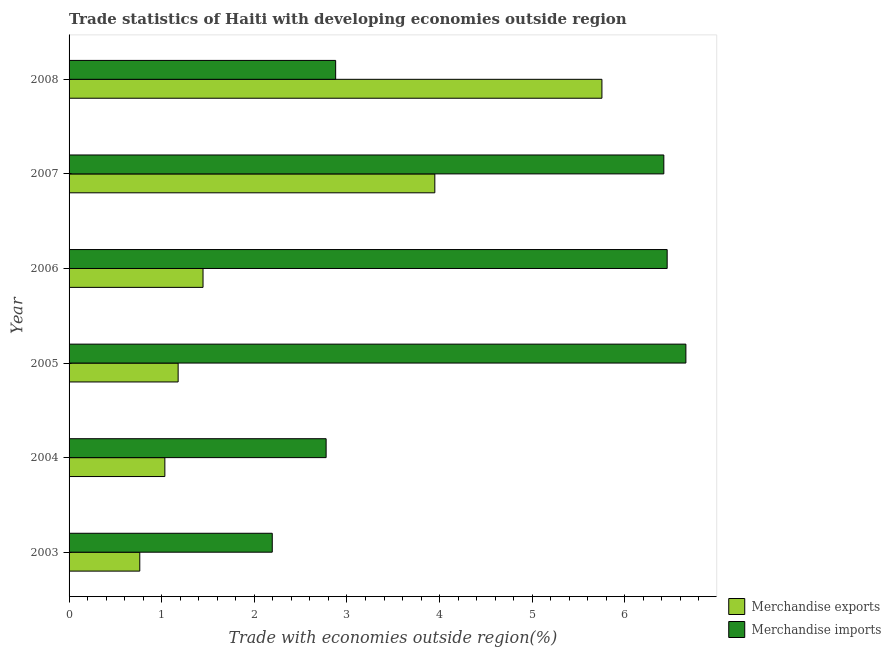How many groups of bars are there?
Ensure brevity in your answer.  6. Are the number of bars per tick equal to the number of legend labels?
Provide a succinct answer. Yes. How many bars are there on the 5th tick from the top?
Ensure brevity in your answer.  2. What is the label of the 5th group of bars from the top?
Offer a terse response. 2004. In how many cases, is the number of bars for a given year not equal to the number of legend labels?
Offer a very short reply. 0. What is the merchandise imports in 2004?
Offer a very short reply. 2.78. Across all years, what is the maximum merchandise imports?
Keep it short and to the point. 6.66. Across all years, what is the minimum merchandise exports?
Keep it short and to the point. 0.76. In which year was the merchandise exports minimum?
Offer a very short reply. 2003. What is the total merchandise exports in the graph?
Provide a short and direct response. 14.12. What is the difference between the merchandise exports in 2005 and that in 2007?
Provide a succinct answer. -2.77. What is the difference between the merchandise exports in 2004 and the merchandise imports in 2005?
Keep it short and to the point. -5.62. What is the average merchandise imports per year?
Your answer should be compact. 4.56. In the year 2005, what is the difference between the merchandise imports and merchandise exports?
Provide a succinct answer. 5.48. In how many years, is the merchandise exports greater than 6.6 %?
Make the answer very short. 0. Is the merchandise exports in 2006 less than that in 2008?
Make the answer very short. Yes. Is the difference between the merchandise exports in 2004 and 2007 greater than the difference between the merchandise imports in 2004 and 2007?
Your response must be concise. Yes. What is the difference between the highest and the second highest merchandise imports?
Provide a short and direct response. 0.2. What is the difference between the highest and the lowest merchandise exports?
Offer a terse response. 4.99. In how many years, is the merchandise imports greater than the average merchandise imports taken over all years?
Offer a very short reply. 3. Is the sum of the merchandise exports in 2003 and 2008 greater than the maximum merchandise imports across all years?
Provide a short and direct response. No. What does the 1st bar from the top in 2008 represents?
Give a very brief answer. Merchandise imports. What does the 2nd bar from the bottom in 2004 represents?
Give a very brief answer. Merchandise imports. Are all the bars in the graph horizontal?
Make the answer very short. Yes. Does the graph contain any zero values?
Provide a short and direct response. No. Does the graph contain grids?
Offer a terse response. No. Where does the legend appear in the graph?
Ensure brevity in your answer.  Bottom right. How many legend labels are there?
Ensure brevity in your answer.  2. How are the legend labels stacked?
Offer a very short reply. Vertical. What is the title of the graph?
Provide a short and direct response. Trade statistics of Haiti with developing economies outside region. What is the label or title of the X-axis?
Keep it short and to the point. Trade with economies outside region(%). What is the Trade with economies outside region(%) in Merchandise exports in 2003?
Offer a terse response. 0.76. What is the Trade with economies outside region(%) in Merchandise imports in 2003?
Your response must be concise. 2.19. What is the Trade with economies outside region(%) of Merchandise exports in 2004?
Give a very brief answer. 1.03. What is the Trade with economies outside region(%) of Merchandise imports in 2004?
Provide a short and direct response. 2.78. What is the Trade with economies outside region(%) in Merchandise exports in 2005?
Ensure brevity in your answer.  1.18. What is the Trade with economies outside region(%) in Merchandise imports in 2005?
Ensure brevity in your answer.  6.66. What is the Trade with economies outside region(%) in Merchandise exports in 2006?
Keep it short and to the point. 1.45. What is the Trade with economies outside region(%) of Merchandise imports in 2006?
Ensure brevity in your answer.  6.46. What is the Trade with economies outside region(%) in Merchandise exports in 2007?
Give a very brief answer. 3.95. What is the Trade with economies outside region(%) in Merchandise imports in 2007?
Give a very brief answer. 6.42. What is the Trade with economies outside region(%) of Merchandise exports in 2008?
Your answer should be compact. 5.75. What is the Trade with economies outside region(%) of Merchandise imports in 2008?
Your answer should be compact. 2.88. Across all years, what is the maximum Trade with economies outside region(%) in Merchandise exports?
Your answer should be very brief. 5.75. Across all years, what is the maximum Trade with economies outside region(%) of Merchandise imports?
Give a very brief answer. 6.66. Across all years, what is the minimum Trade with economies outside region(%) in Merchandise exports?
Your response must be concise. 0.76. Across all years, what is the minimum Trade with economies outside region(%) of Merchandise imports?
Provide a short and direct response. 2.19. What is the total Trade with economies outside region(%) of Merchandise exports in the graph?
Your answer should be compact. 14.12. What is the total Trade with economies outside region(%) in Merchandise imports in the graph?
Your answer should be compact. 27.38. What is the difference between the Trade with economies outside region(%) in Merchandise exports in 2003 and that in 2004?
Provide a short and direct response. -0.27. What is the difference between the Trade with economies outside region(%) of Merchandise imports in 2003 and that in 2004?
Ensure brevity in your answer.  -0.58. What is the difference between the Trade with economies outside region(%) of Merchandise exports in 2003 and that in 2005?
Your answer should be compact. -0.41. What is the difference between the Trade with economies outside region(%) of Merchandise imports in 2003 and that in 2005?
Make the answer very short. -4.47. What is the difference between the Trade with economies outside region(%) in Merchandise exports in 2003 and that in 2006?
Offer a very short reply. -0.68. What is the difference between the Trade with economies outside region(%) of Merchandise imports in 2003 and that in 2006?
Provide a short and direct response. -4.26. What is the difference between the Trade with economies outside region(%) of Merchandise exports in 2003 and that in 2007?
Make the answer very short. -3.19. What is the difference between the Trade with economies outside region(%) of Merchandise imports in 2003 and that in 2007?
Provide a succinct answer. -4.23. What is the difference between the Trade with economies outside region(%) of Merchandise exports in 2003 and that in 2008?
Provide a short and direct response. -4.99. What is the difference between the Trade with economies outside region(%) in Merchandise imports in 2003 and that in 2008?
Your response must be concise. -0.68. What is the difference between the Trade with economies outside region(%) of Merchandise exports in 2004 and that in 2005?
Keep it short and to the point. -0.14. What is the difference between the Trade with economies outside region(%) of Merchandise imports in 2004 and that in 2005?
Provide a succinct answer. -3.88. What is the difference between the Trade with economies outside region(%) in Merchandise exports in 2004 and that in 2006?
Provide a short and direct response. -0.41. What is the difference between the Trade with economies outside region(%) of Merchandise imports in 2004 and that in 2006?
Your response must be concise. -3.68. What is the difference between the Trade with economies outside region(%) of Merchandise exports in 2004 and that in 2007?
Give a very brief answer. -2.91. What is the difference between the Trade with economies outside region(%) in Merchandise imports in 2004 and that in 2007?
Your answer should be compact. -3.65. What is the difference between the Trade with economies outside region(%) of Merchandise exports in 2004 and that in 2008?
Provide a short and direct response. -4.72. What is the difference between the Trade with economies outside region(%) of Merchandise imports in 2004 and that in 2008?
Make the answer very short. -0.1. What is the difference between the Trade with economies outside region(%) in Merchandise exports in 2005 and that in 2006?
Your response must be concise. -0.27. What is the difference between the Trade with economies outside region(%) in Merchandise imports in 2005 and that in 2006?
Provide a short and direct response. 0.2. What is the difference between the Trade with economies outside region(%) in Merchandise exports in 2005 and that in 2007?
Provide a short and direct response. -2.77. What is the difference between the Trade with economies outside region(%) of Merchandise imports in 2005 and that in 2007?
Make the answer very short. 0.24. What is the difference between the Trade with economies outside region(%) in Merchandise exports in 2005 and that in 2008?
Your response must be concise. -4.57. What is the difference between the Trade with economies outside region(%) in Merchandise imports in 2005 and that in 2008?
Your answer should be very brief. 3.78. What is the difference between the Trade with economies outside region(%) in Merchandise exports in 2006 and that in 2007?
Make the answer very short. -2.5. What is the difference between the Trade with economies outside region(%) in Merchandise imports in 2006 and that in 2007?
Give a very brief answer. 0.04. What is the difference between the Trade with economies outside region(%) in Merchandise exports in 2006 and that in 2008?
Your response must be concise. -4.31. What is the difference between the Trade with economies outside region(%) in Merchandise imports in 2006 and that in 2008?
Keep it short and to the point. 3.58. What is the difference between the Trade with economies outside region(%) in Merchandise exports in 2007 and that in 2008?
Give a very brief answer. -1.8. What is the difference between the Trade with economies outside region(%) of Merchandise imports in 2007 and that in 2008?
Provide a succinct answer. 3.54. What is the difference between the Trade with economies outside region(%) of Merchandise exports in 2003 and the Trade with economies outside region(%) of Merchandise imports in 2004?
Offer a very short reply. -2.01. What is the difference between the Trade with economies outside region(%) of Merchandise exports in 2003 and the Trade with economies outside region(%) of Merchandise imports in 2005?
Provide a succinct answer. -5.9. What is the difference between the Trade with economies outside region(%) of Merchandise exports in 2003 and the Trade with economies outside region(%) of Merchandise imports in 2006?
Your answer should be compact. -5.69. What is the difference between the Trade with economies outside region(%) in Merchandise exports in 2003 and the Trade with economies outside region(%) in Merchandise imports in 2007?
Keep it short and to the point. -5.66. What is the difference between the Trade with economies outside region(%) in Merchandise exports in 2003 and the Trade with economies outside region(%) in Merchandise imports in 2008?
Your response must be concise. -2.11. What is the difference between the Trade with economies outside region(%) in Merchandise exports in 2004 and the Trade with economies outside region(%) in Merchandise imports in 2005?
Your answer should be very brief. -5.62. What is the difference between the Trade with economies outside region(%) of Merchandise exports in 2004 and the Trade with economies outside region(%) of Merchandise imports in 2006?
Provide a short and direct response. -5.42. What is the difference between the Trade with economies outside region(%) in Merchandise exports in 2004 and the Trade with economies outside region(%) in Merchandise imports in 2007?
Your response must be concise. -5.39. What is the difference between the Trade with economies outside region(%) in Merchandise exports in 2004 and the Trade with economies outside region(%) in Merchandise imports in 2008?
Make the answer very short. -1.84. What is the difference between the Trade with economies outside region(%) in Merchandise exports in 2005 and the Trade with economies outside region(%) in Merchandise imports in 2006?
Offer a very short reply. -5.28. What is the difference between the Trade with economies outside region(%) of Merchandise exports in 2005 and the Trade with economies outside region(%) of Merchandise imports in 2007?
Give a very brief answer. -5.24. What is the difference between the Trade with economies outside region(%) in Merchandise exports in 2005 and the Trade with economies outside region(%) in Merchandise imports in 2008?
Provide a short and direct response. -1.7. What is the difference between the Trade with economies outside region(%) of Merchandise exports in 2006 and the Trade with economies outside region(%) of Merchandise imports in 2007?
Provide a succinct answer. -4.97. What is the difference between the Trade with economies outside region(%) of Merchandise exports in 2006 and the Trade with economies outside region(%) of Merchandise imports in 2008?
Make the answer very short. -1.43. What is the difference between the Trade with economies outside region(%) in Merchandise exports in 2007 and the Trade with economies outside region(%) in Merchandise imports in 2008?
Provide a succinct answer. 1.07. What is the average Trade with economies outside region(%) in Merchandise exports per year?
Your response must be concise. 2.35. What is the average Trade with economies outside region(%) in Merchandise imports per year?
Provide a succinct answer. 4.56. In the year 2003, what is the difference between the Trade with economies outside region(%) of Merchandise exports and Trade with economies outside region(%) of Merchandise imports?
Provide a succinct answer. -1.43. In the year 2004, what is the difference between the Trade with economies outside region(%) in Merchandise exports and Trade with economies outside region(%) in Merchandise imports?
Ensure brevity in your answer.  -1.74. In the year 2005, what is the difference between the Trade with economies outside region(%) of Merchandise exports and Trade with economies outside region(%) of Merchandise imports?
Offer a very short reply. -5.48. In the year 2006, what is the difference between the Trade with economies outside region(%) in Merchandise exports and Trade with economies outside region(%) in Merchandise imports?
Offer a terse response. -5.01. In the year 2007, what is the difference between the Trade with economies outside region(%) in Merchandise exports and Trade with economies outside region(%) in Merchandise imports?
Your answer should be very brief. -2.47. In the year 2008, what is the difference between the Trade with economies outside region(%) of Merchandise exports and Trade with economies outside region(%) of Merchandise imports?
Provide a short and direct response. 2.87. What is the ratio of the Trade with economies outside region(%) of Merchandise exports in 2003 to that in 2004?
Your answer should be compact. 0.74. What is the ratio of the Trade with economies outside region(%) of Merchandise imports in 2003 to that in 2004?
Your answer should be compact. 0.79. What is the ratio of the Trade with economies outside region(%) of Merchandise exports in 2003 to that in 2005?
Keep it short and to the point. 0.65. What is the ratio of the Trade with economies outside region(%) of Merchandise imports in 2003 to that in 2005?
Provide a short and direct response. 0.33. What is the ratio of the Trade with economies outside region(%) in Merchandise exports in 2003 to that in 2006?
Provide a short and direct response. 0.53. What is the ratio of the Trade with economies outside region(%) of Merchandise imports in 2003 to that in 2006?
Keep it short and to the point. 0.34. What is the ratio of the Trade with economies outside region(%) of Merchandise exports in 2003 to that in 2007?
Your response must be concise. 0.19. What is the ratio of the Trade with economies outside region(%) of Merchandise imports in 2003 to that in 2007?
Make the answer very short. 0.34. What is the ratio of the Trade with economies outside region(%) in Merchandise exports in 2003 to that in 2008?
Your response must be concise. 0.13. What is the ratio of the Trade with economies outside region(%) of Merchandise imports in 2003 to that in 2008?
Your answer should be very brief. 0.76. What is the ratio of the Trade with economies outside region(%) of Merchandise exports in 2004 to that in 2005?
Offer a terse response. 0.88. What is the ratio of the Trade with economies outside region(%) in Merchandise imports in 2004 to that in 2005?
Your response must be concise. 0.42. What is the ratio of the Trade with economies outside region(%) in Merchandise exports in 2004 to that in 2006?
Your answer should be very brief. 0.72. What is the ratio of the Trade with economies outside region(%) in Merchandise imports in 2004 to that in 2006?
Make the answer very short. 0.43. What is the ratio of the Trade with economies outside region(%) in Merchandise exports in 2004 to that in 2007?
Your answer should be very brief. 0.26. What is the ratio of the Trade with economies outside region(%) of Merchandise imports in 2004 to that in 2007?
Provide a short and direct response. 0.43. What is the ratio of the Trade with economies outside region(%) in Merchandise exports in 2004 to that in 2008?
Offer a terse response. 0.18. What is the ratio of the Trade with economies outside region(%) of Merchandise imports in 2004 to that in 2008?
Make the answer very short. 0.96. What is the ratio of the Trade with economies outside region(%) of Merchandise exports in 2005 to that in 2006?
Keep it short and to the point. 0.81. What is the ratio of the Trade with economies outside region(%) in Merchandise imports in 2005 to that in 2006?
Ensure brevity in your answer.  1.03. What is the ratio of the Trade with economies outside region(%) in Merchandise exports in 2005 to that in 2007?
Give a very brief answer. 0.3. What is the ratio of the Trade with economies outside region(%) in Merchandise imports in 2005 to that in 2007?
Ensure brevity in your answer.  1.04. What is the ratio of the Trade with economies outside region(%) of Merchandise exports in 2005 to that in 2008?
Offer a terse response. 0.2. What is the ratio of the Trade with economies outside region(%) in Merchandise imports in 2005 to that in 2008?
Provide a short and direct response. 2.31. What is the ratio of the Trade with economies outside region(%) of Merchandise exports in 2006 to that in 2007?
Give a very brief answer. 0.37. What is the ratio of the Trade with economies outside region(%) of Merchandise imports in 2006 to that in 2007?
Make the answer very short. 1.01. What is the ratio of the Trade with economies outside region(%) in Merchandise exports in 2006 to that in 2008?
Offer a terse response. 0.25. What is the ratio of the Trade with economies outside region(%) in Merchandise imports in 2006 to that in 2008?
Keep it short and to the point. 2.24. What is the ratio of the Trade with economies outside region(%) of Merchandise exports in 2007 to that in 2008?
Give a very brief answer. 0.69. What is the ratio of the Trade with economies outside region(%) in Merchandise imports in 2007 to that in 2008?
Make the answer very short. 2.23. What is the difference between the highest and the second highest Trade with economies outside region(%) of Merchandise exports?
Make the answer very short. 1.8. What is the difference between the highest and the second highest Trade with economies outside region(%) in Merchandise imports?
Give a very brief answer. 0.2. What is the difference between the highest and the lowest Trade with economies outside region(%) of Merchandise exports?
Offer a very short reply. 4.99. What is the difference between the highest and the lowest Trade with economies outside region(%) of Merchandise imports?
Ensure brevity in your answer.  4.47. 